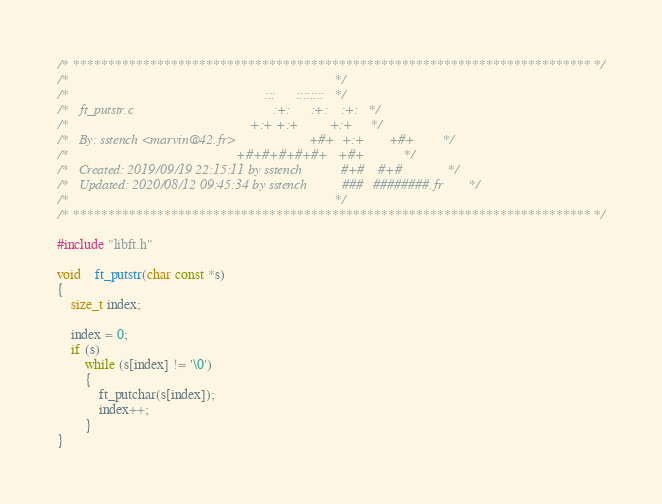<code> <loc_0><loc_0><loc_500><loc_500><_C_>/* ************************************************************************** */
/*                                                                            */
/*                                                        :::      ::::::::   */
/*   ft_putstr.c                                        :+:      :+:    :+:   */
/*                                                    +:+ +:+         +:+     */
/*   By: sstench <marvin@42.fr>                     +#+  +:+       +#+        */
/*                                                +#+#+#+#+#+   +#+           */
/*   Created: 2019/09/19 22:15:11 by sstench           #+#    #+#             */
/*   Updated: 2020/08/12 09:45:34 by sstench          ###   ########.fr       */
/*                                                                            */
/* ************************************************************************** */

#include "libft.h"

void	ft_putstr(char const *s)
{
	size_t index;

	index = 0;
	if (s)
		while (s[index] != '\0')
		{
			ft_putchar(s[index]);
			index++;
		}
}
</code> 